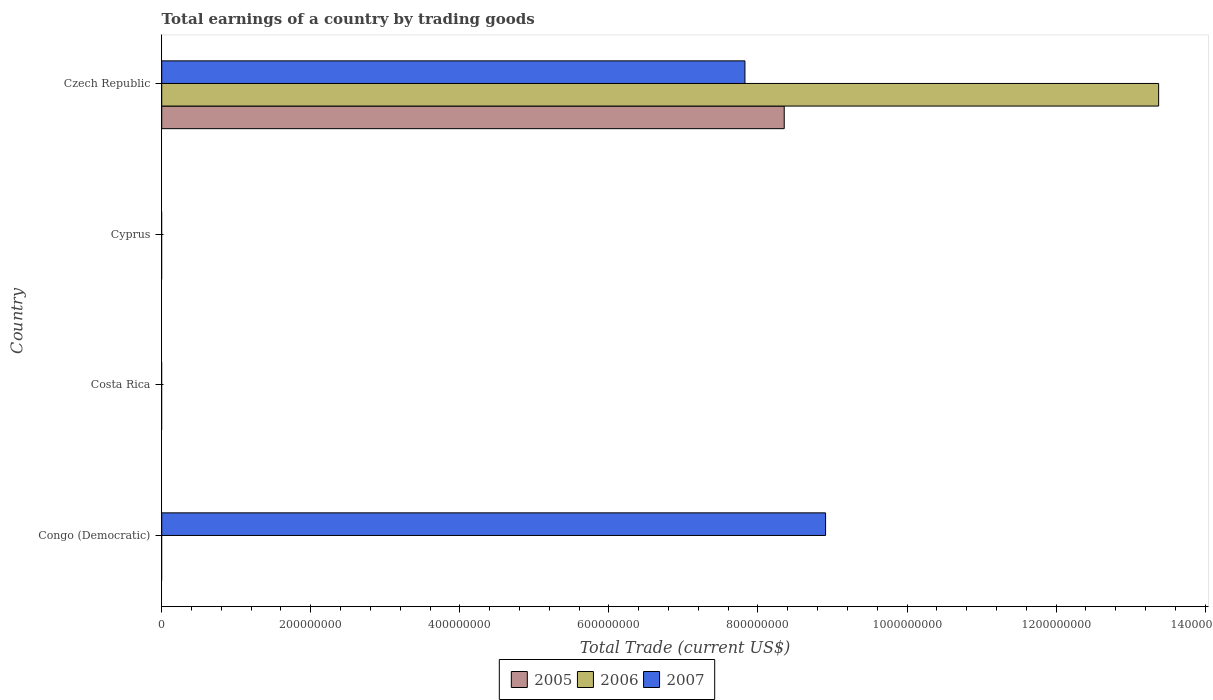How many different coloured bars are there?
Your response must be concise. 3. Are the number of bars per tick equal to the number of legend labels?
Offer a terse response. No. Are the number of bars on each tick of the Y-axis equal?
Make the answer very short. No. How many bars are there on the 4th tick from the top?
Your answer should be compact. 1. What is the label of the 2nd group of bars from the top?
Provide a short and direct response. Cyprus. Across all countries, what is the maximum total earnings in 2007?
Provide a short and direct response. 8.91e+08. In which country was the total earnings in 2005 maximum?
Your answer should be compact. Czech Republic. What is the total total earnings in 2005 in the graph?
Your answer should be compact. 8.35e+08. What is the difference between the total earnings in 2006 in Cyprus and the total earnings in 2007 in Congo (Democratic)?
Your response must be concise. -8.91e+08. What is the average total earnings in 2006 per country?
Provide a succinct answer. 3.34e+08. What is the difference between the total earnings in 2005 and total earnings in 2006 in Czech Republic?
Your answer should be compact. -5.02e+08. What is the ratio of the total earnings in 2007 in Congo (Democratic) to that in Czech Republic?
Give a very brief answer. 1.14. What is the difference between the highest and the lowest total earnings in 2007?
Your answer should be very brief. 8.91e+08. How many bars are there?
Offer a very short reply. 4. How many countries are there in the graph?
Ensure brevity in your answer.  4. What is the difference between two consecutive major ticks on the X-axis?
Your answer should be very brief. 2.00e+08. Are the values on the major ticks of X-axis written in scientific E-notation?
Your response must be concise. No. Does the graph contain any zero values?
Keep it short and to the point. Yes. Does the graph contain grids?
Give a very brief answer. No. How many legend labels are there?
Provide a succinct answer. 3. What is the title of the graph?
Your answer should be very brief. Total earnings of a country by trading goods. What is the label or title of the X-axis?
Make the answer very short. Total Trade (current US$). What is the Total Trade (current US$) of 2005 in Congo (Democratic)?
Offer a very short reply. 0. What is the Total Trade (current US$) in 2006 in Congo (Democratic)?
Your response must be concise. 0. What is the Total Trade (current US$) in 2007 in Congo (Democratic)?
Offer a terse response. 8.91e+08. What is the Total Trade (current US$) of 2006 in Costa Rica?
Make the answer very short. 0. What is the Total Trade (current US$) in 2007 in Costa Rica?
Offer a very short reply. 0. What is the Total Trade (current US$) in 2005 in Cyprus?
Provide a short and direct response. 0. What is the Total Trade (current US$) in 2006 in Cyprus?
Offer a very short reply. 0. What is the Total Trade (current US$) in 2005 in Czech Republic?
Your response must be concise. 8.35e+08. What is the Total Trade (current US$) of 2006 in Czech Republic?
Make the answer very short. 1.34e+09. What is the Total Trade (current US$) in 2007 in Czech Republic?
Provide a succinct answer. 7.83e+08. Across all countries, what is the maximum Total Trade (current US$) of 2005?
Provide a succinct answer. 8.35e+08. Across all countries, what is the maximum Total Trade (current US$) of 2006?
Your answer should be very brief. 1.34e+09. Across all countries, what is the maximum Total Trade (current US$) in 2007?
Your response must be concise. 8.91e+08. Across all countries, what is the minimum Total Trade (current US$) in 2005?
Make the answer very short. 0. Across all countries, what is the minimum Total Trade (current US$) of 2006?
Your answer should be compact. 0. What is the total Total Trade (current US$) in 2005 in the graph?
Ensure brevity in your answer.  8.35e+08. What is the total Total Trade (current US$) in 2006 in the graph?
Your answer should be very brief. 1.34e+09. What is the total Total Trade (current US$) of 2007 in the graph?
Give a very brief answer. 1.67e+09. What is the difference between the Total Trade (current US$) in 2007 in Congo (Democratic) and that in Czech Republic?
Give a very brief answer. 1.08e+08. What is the average Total Trade (current US$) of 2005 per country?
Ensure brevity in your answer.  2.09e+08. What is the average Total Trade (current US$) of 2006 per country?
Give a very brief answer. 3.34e+08. What is the average Total Trade (current US$) of 2007 per country?
Offer a very short reply. 4.18e+08. What is the difference between the Total Trade (current US$) of 2005 and Total Trade (current US$) of 2006 in Czech Republic?
Ensure brevity in your answer.  -5.02e+08. What is the difference between the Total Trade (current US$) in 2005 and Total Trade (current US$) in 2007 in Czech Republic?
Your answer should be very brief. 5.27e+07. What is the difference between the Total Trade (current US$) of 2006 and Total Trade (current US$) of 2007 in Czech Republic?
Offer a very short reply. 5.55e+08. What is the ratio of the Total Trade (current US$) of 2007 in Congo (Democratic) to that in Czech Republic?
Your answer should be very brief. 1.14. What is the difference between the highest and the lowest Total Trade (current US$) of 2005?
Your answer should be compact. 8.35e+08. What is the difference between the highest and the lowest Total Trade (current US$) of 2006?
Provide a succinct answer. 1.34e+09. What is the difference between the highest and the lowest Total Trade (current US$) in 2007?
Your answer should be very brief. 8.91e+08. 